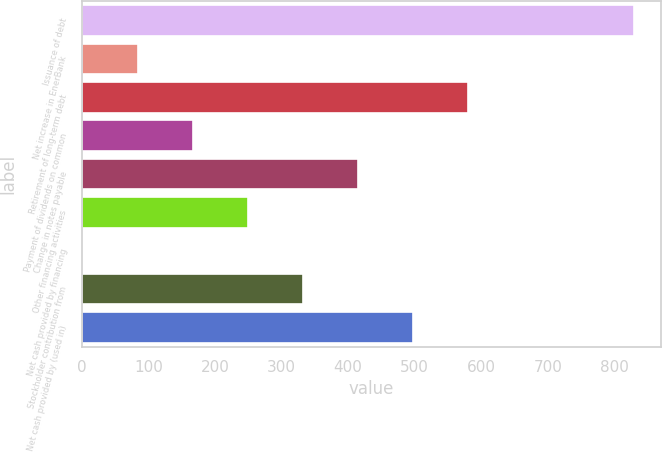<chart> <loc_0><loc_0><loc_500><loc_500><bar_chart><fcel>Issuance of debt<fcel>Net increase in EnerBank<fcel>Retirement of long-term debt<fcel>Payment of dividends on common<fcel>Change in notes payable<fcel>Other financing activities<fcel>Net cash provided by financing<fcel>Stockholder contribution from<fcel>Net cash provided by (used in)<nl><fcel>829<fcel>83.8<fcel>580.6<fcel>166.6<fcel>415<fcel>249.4<fcel>1<fcel>332.2<fcel>497.8<nl></chart> 